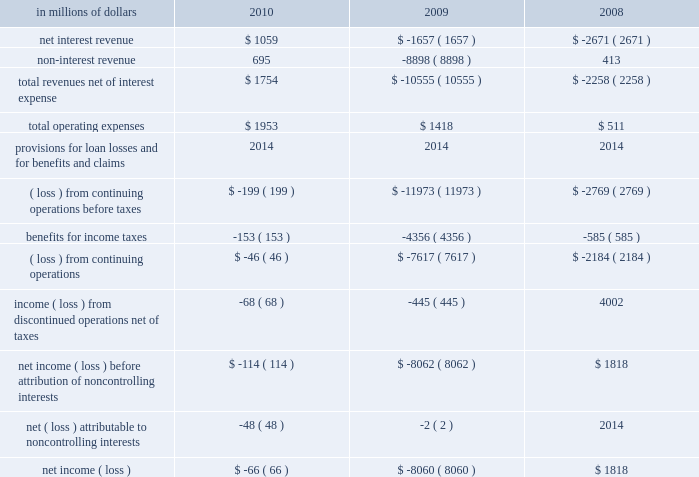Corporate/other corporate/other includes global staff functions ( including finance , risk , human resources , legal and compliance ) and other corporate expense , global operations and technology , residual corporate treasury and corporate items .
At december 31 , 2010 , this segment had approximately $ 272 billion of assets , consisting primarily of citi 2019s liquidity portfolio , including $ 87 billion of cash and deposits with banks. .
2010 vs .
2009 revenues , net of interest expense increased primarily due to the absence of the loss on debt extinguishment related to the repayment of the $ 20 billion of tarp trust preferred securities and the exit from the loss-sharing agreement with the u.s .
Government , each in the fourth quarter of 2009 .
Revenues also increased due to gains on sales of afs securities , benefits from lower short- term interest rates and other improved treasury results during the current year .
These increases were partially offset by the absence of the pretax gain related to citi 2019s public and private exchange offers in 2009 .
Operating expenses increased primarily due to various legal and related expenses , as well as other non-compensation expenses .
2009 vs .
2008 revenues , net of interest expense declined primarily due to the pretax loss on debt extinguishment related to the repayment of tarp and the exit from the loss-sharing agreement with the u.s .
Government .
Revenues also declined due to the absence of the 2008 sale of citigroup global services limited recorded in operations and technology .
These declines were partially offset by a pretax gain related to the exchange offers , revenues and higher intersegment eliminations .
Operating expenses increased primarily due to intersegment eliminations and increases in compensation , partially offset by lower repositioning reserves. .
What was the ratio of total operating expenses to net interest income in 2010? 
Computations: (1953 / 1059)
Answer: 1.84419. 